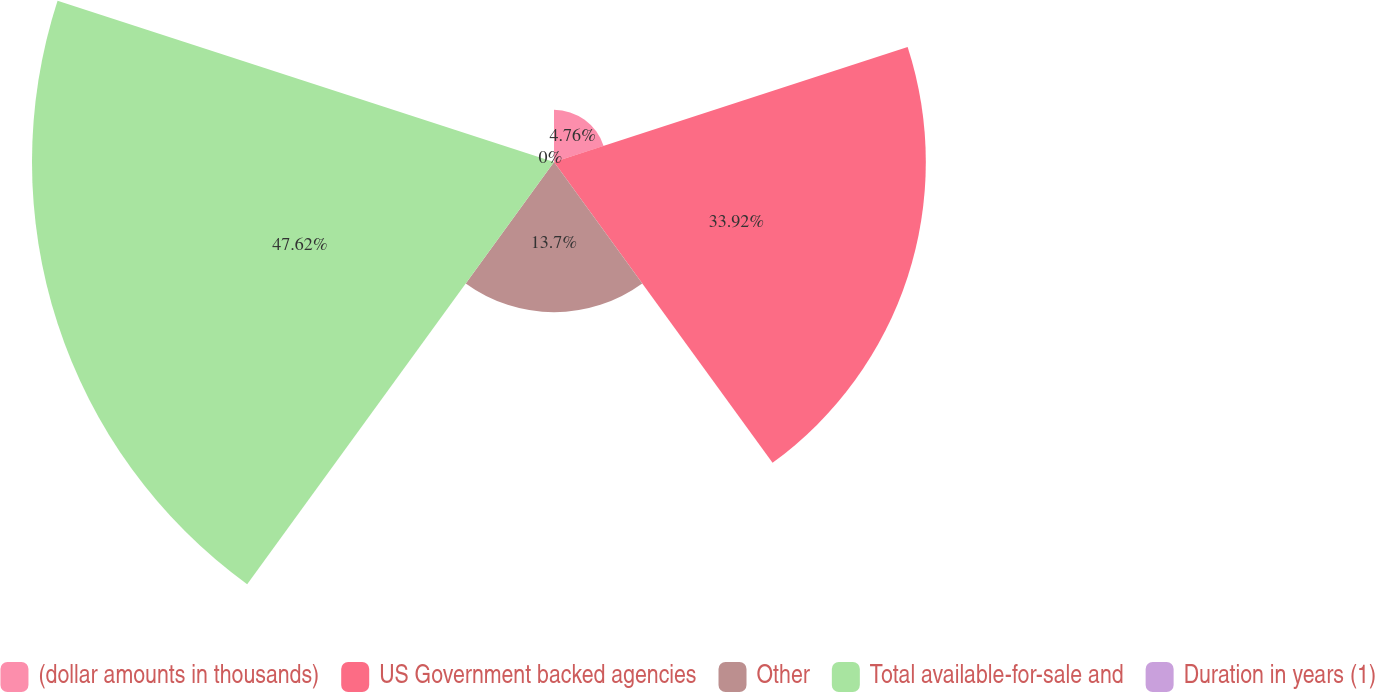Convert chart to OTSL. <chart><loc_0><loc_0><loc_500><loc_500><pie_chart><fcel>(dollar amounts in thousands)<fcel>US Government backed agencies<fcel>Other<fcel>Total available-for-sale and<fcel>Duration in years (1)<nl><fcel>4.76%<fcel>33.92%<fcel>13.7%<fcel>47.62%<fcel>0.0%<nl></chart> 